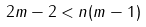Convert formula to latex. <formula><loc_0><loc_0><loc_500><loc_500>2 m - 2 < n ( m - 1 )</formula> 